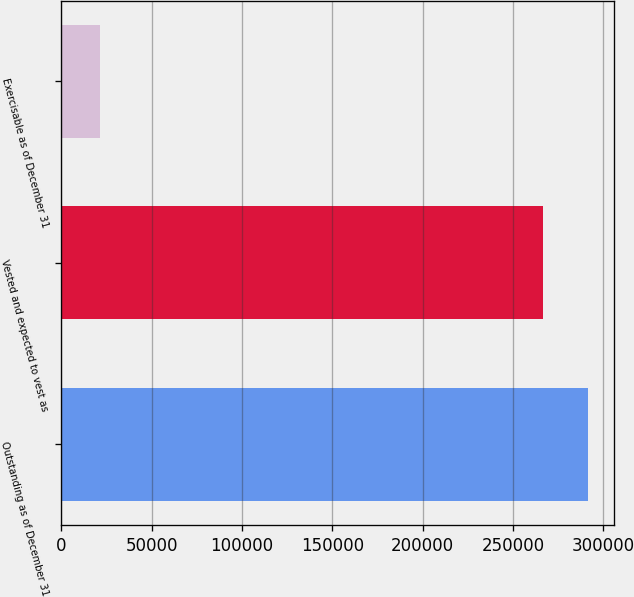Convert chart to OTSL. <chart><loc_0><loc_0><loc_500><loc_500><bar_chart><fcel>Outstanding as of December 31<fcel>Vested and expected to vest as<fcel>Exercisable as of December 31<nl><fcel>291280<fcel>266611<fcel>21701<nl></chart> 